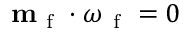<formula> <loc_0><loc_0><loc_500><loc_500>m _ { f } \cdot \omega _ { f } = 0</formula> 